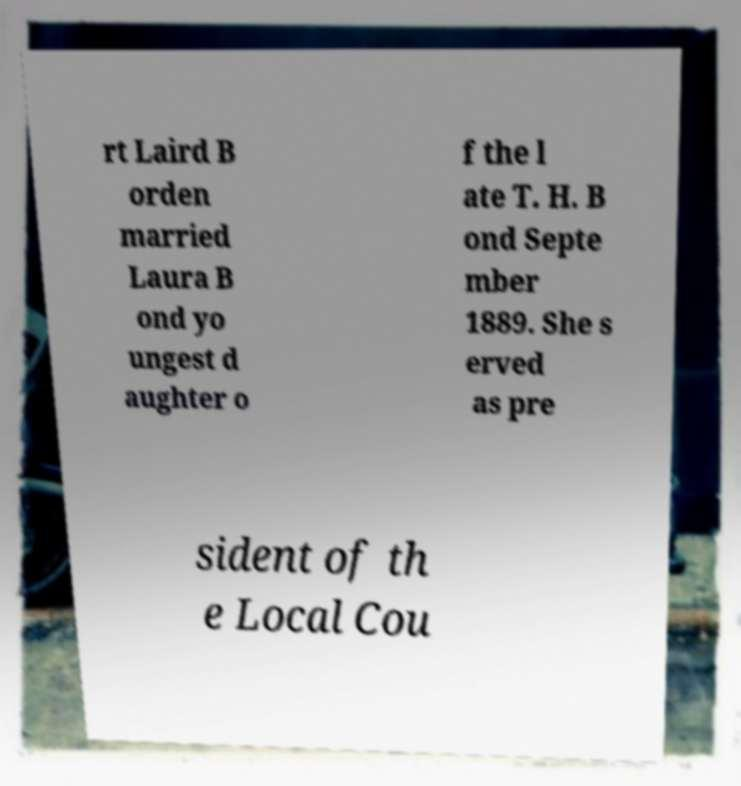Please identify and transcribe the text found in this image. rt Laird B orden married Laura B ond yo ungest d aughter o f the l ate T. H. B ond Septe mber 1889. She s erved as pre sident of th e Local Cou 